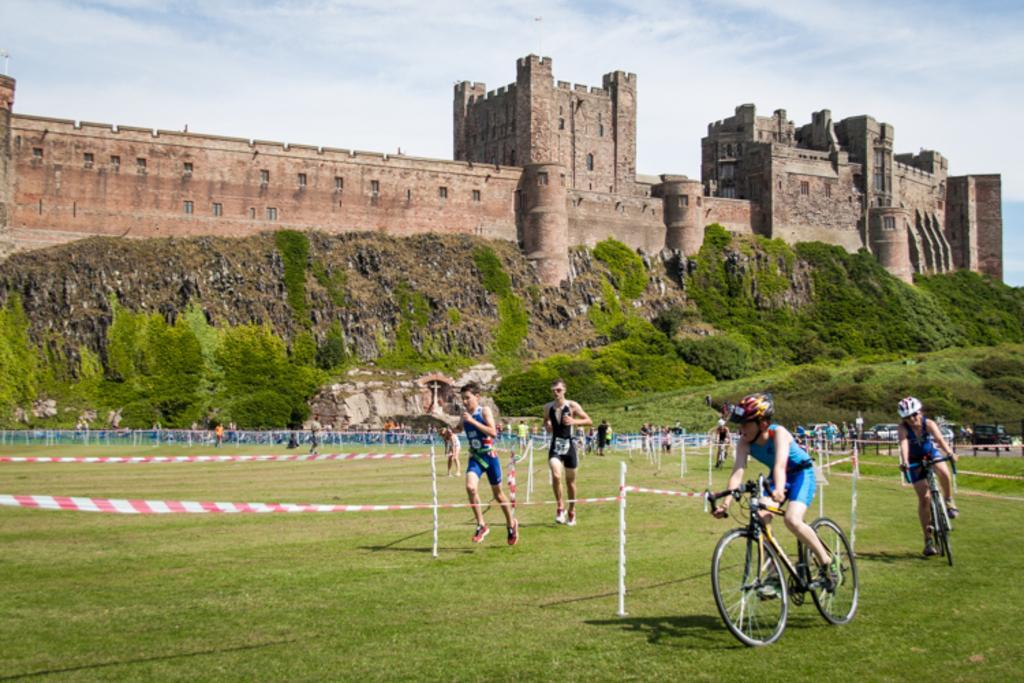Describe this image in one or two sentences. In this image in the center there are some people running, and some of them are sitting on cycle and riding and there are some tapes and rods. At the bottom there is grass, and in the background there are plants, fort and at the top there is sky. 